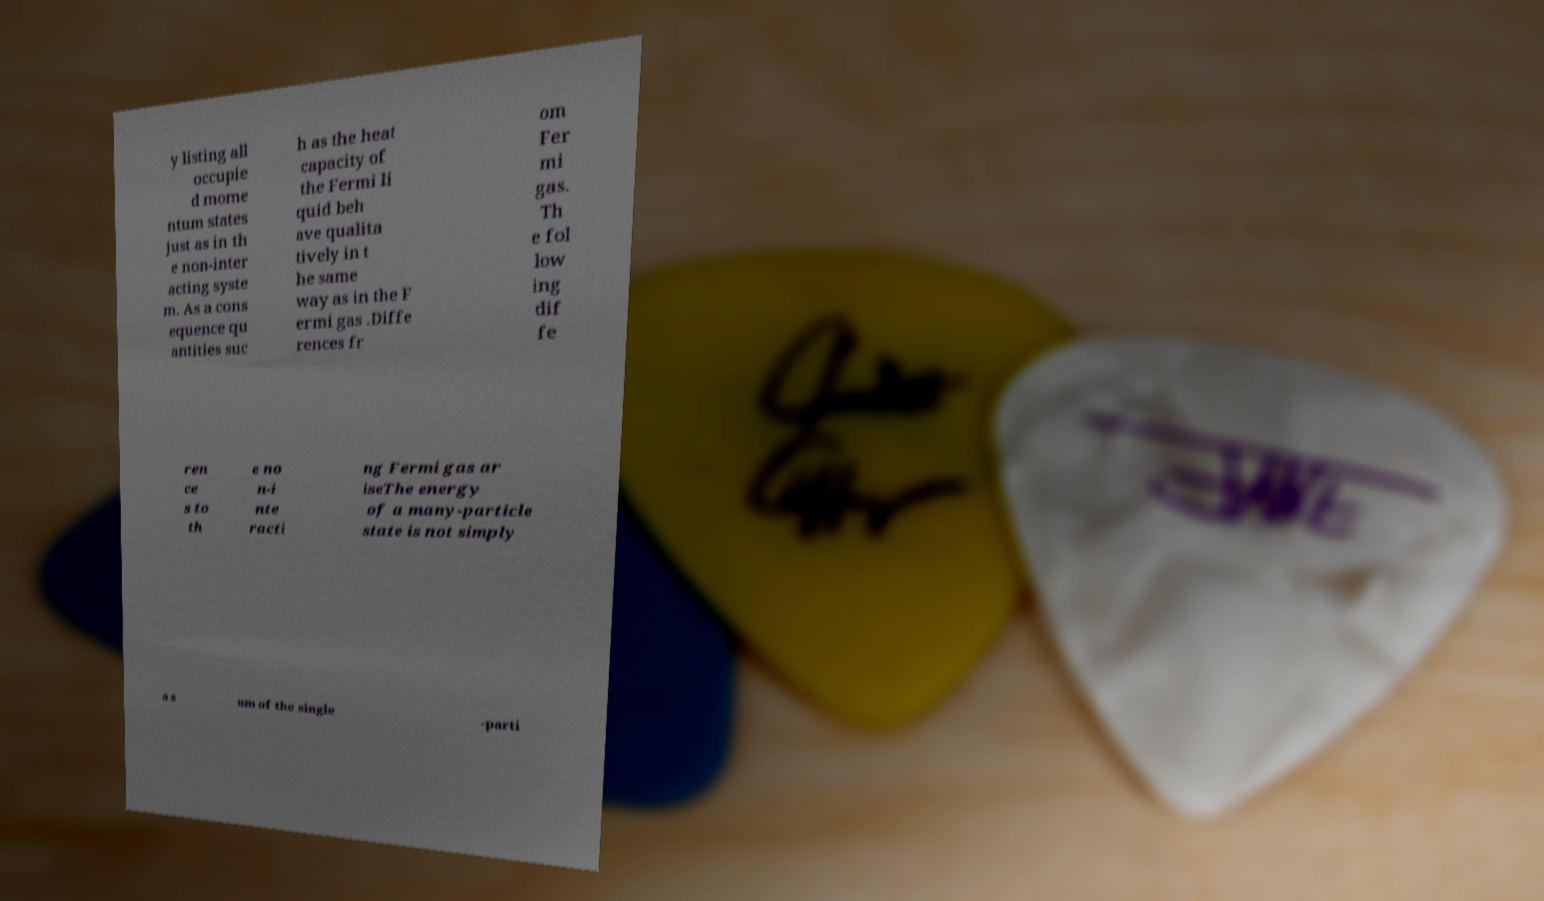For documentation purposes, I need the text within this image transcribed. Could you provide that? y listing all occupie d mome ntum states just as in th e non-inter acting syste m. As a cons equence qu antities suc h as the heat capacity of the Fermi li quid beh ave qualita tively in t he same way as in the F ermi gas .Diffe rences fr om Fer mi gas. Th e fol low ing dif fe ren ce s to th e no n-i nte racti ng Fermi gas ar iseThe energy of a many-particle state is not simply a s um of the single -parti 